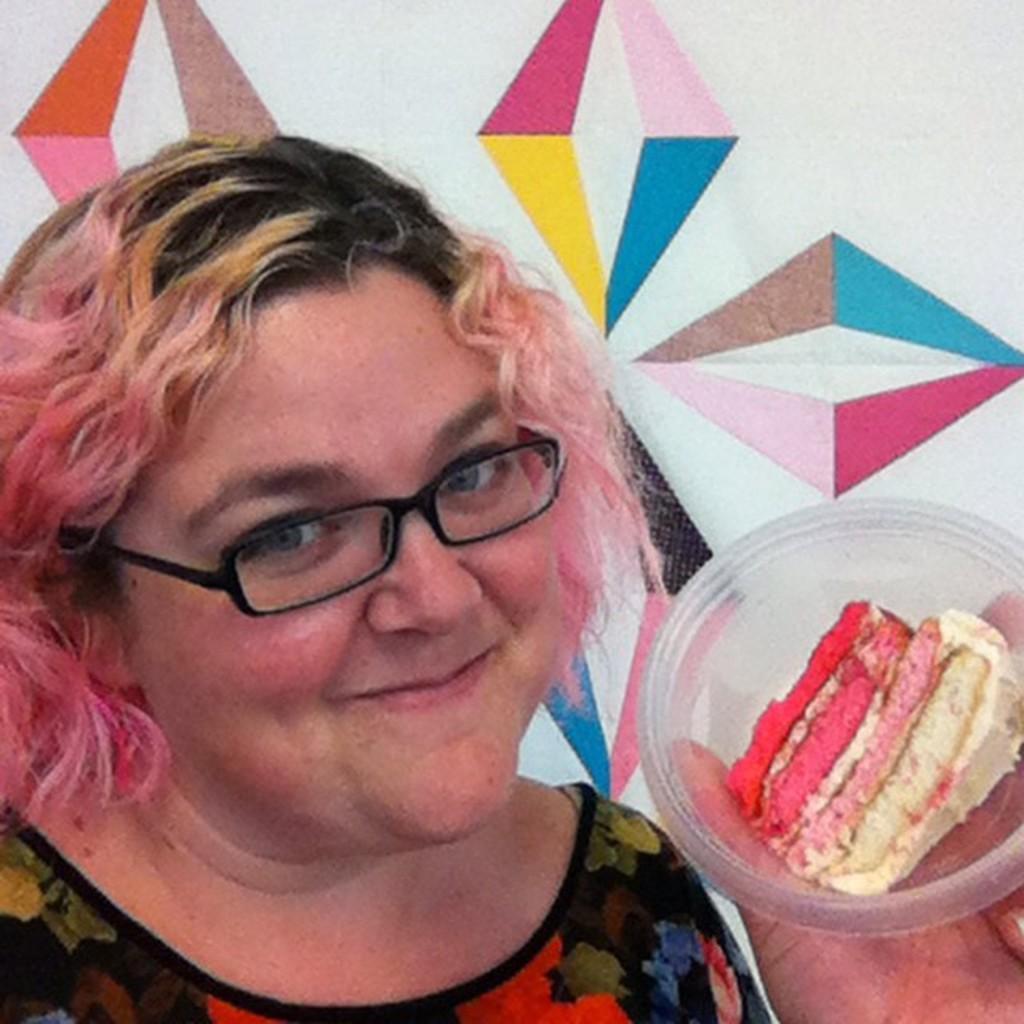Can you describe this image briefly? In this picture we can see a woman is holding a bowl, there is a piece of cake present in the bowl, this woman wore spectacles, it looks like a wall in the background. 